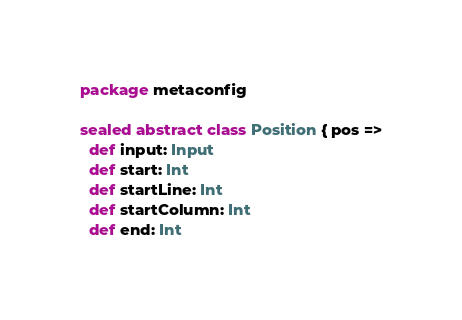Convert code to text. <code><loc_0><loc_0><loc_500><loc_500><_Scala_>package metaconfig

sealed abstract class Position { pos =>
  def input: Input
  def start: Int
  def startLine: Int
  def startColumn: Int
  def end: Int</code> 